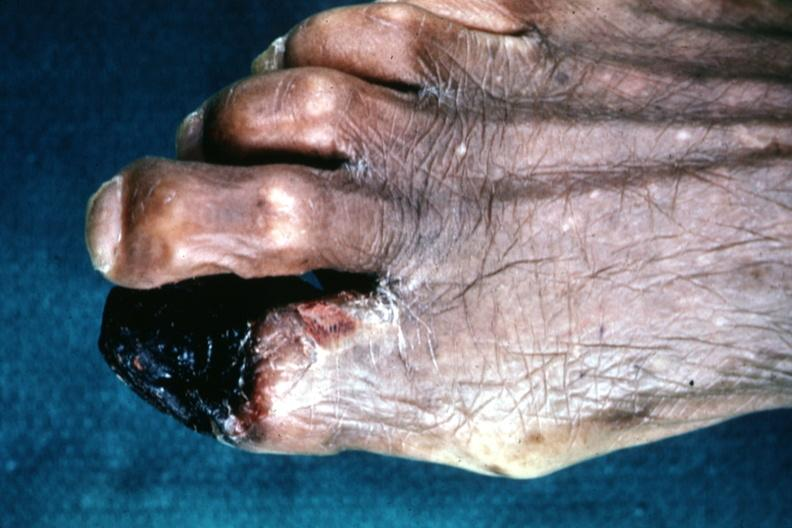does this image show excellent great toe lesion?
Answer the question using a single word or phrase. Yes 